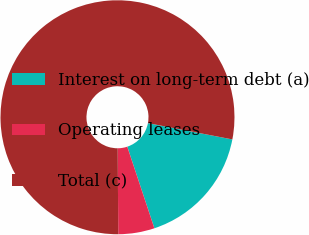<chart> <loc_0><loc_0><loc_500><loc_500><pie_chart><fcel>Interest on long-term debt (a)<fcel>Operating leases<fcel>Total (c)<nl><fcel>16.86%<fcel>5.0%<fcel>78.14%<nl></chart> 